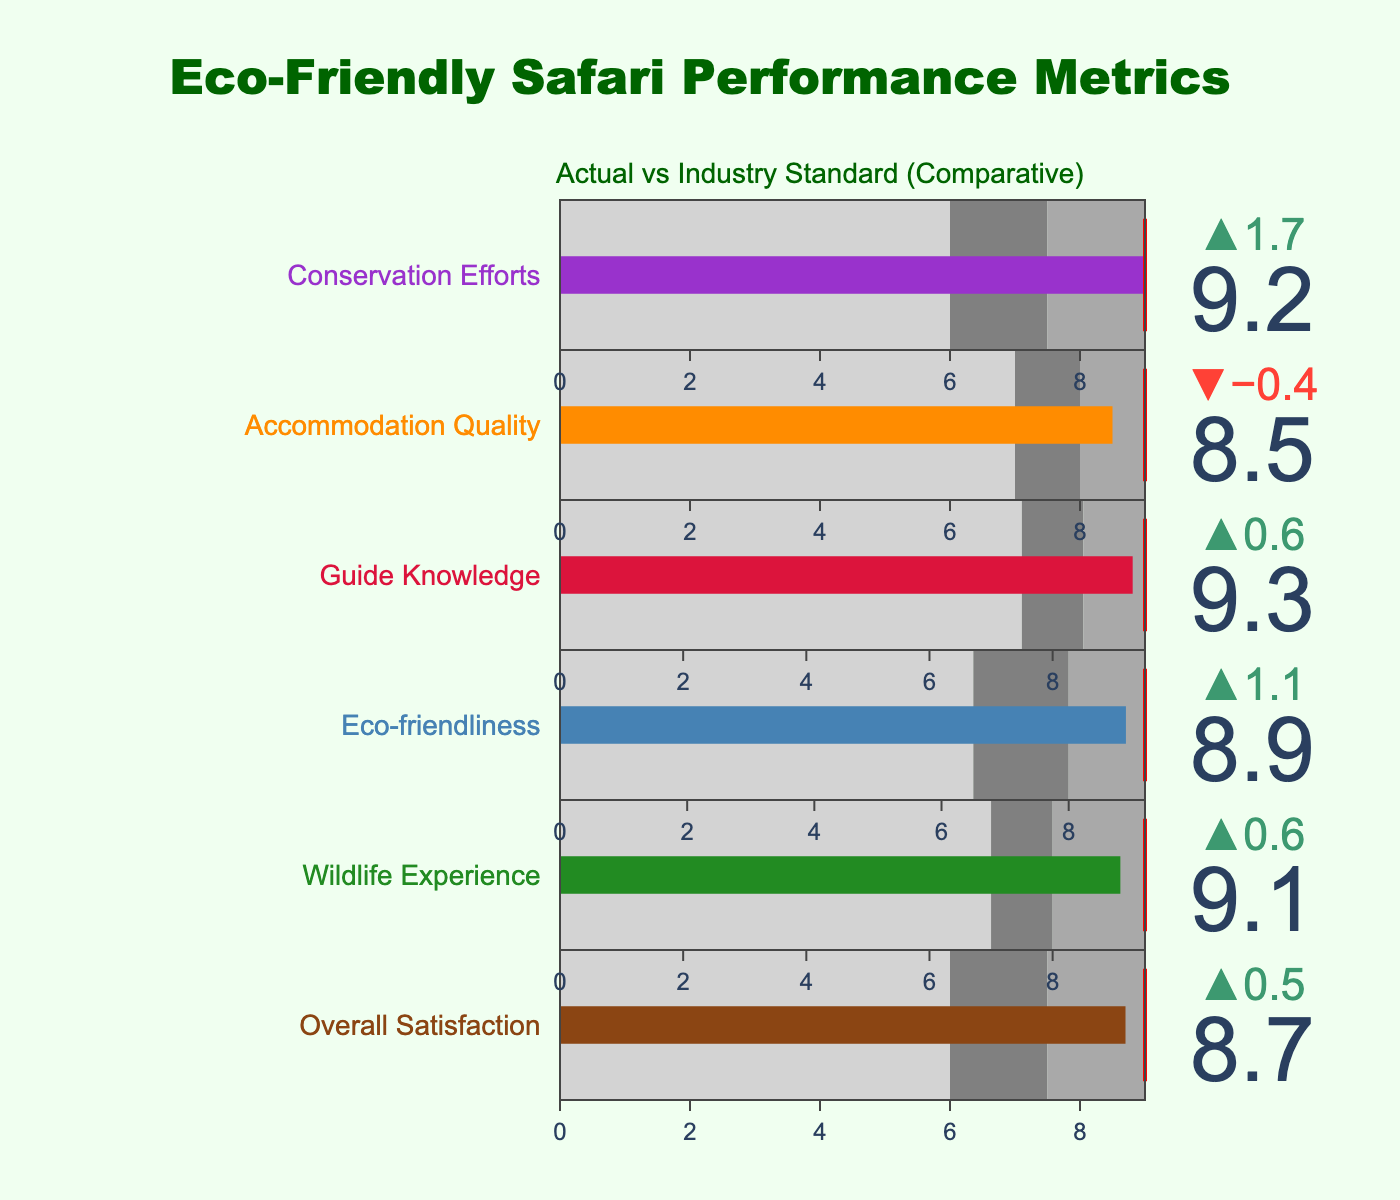What's the title of the figure? The title is prominently placed at the top of the figure and is written in a large, green font. It reads "Eco-Friendly Safari Performance Metrics."
Answer: Eco-Friendly Safari Performance Metrics What is the Actual customer satisfaction rating for Accommodation Quality? The Actual rating for Accommodation Quality is the bar value in the corresponding bullet chart. It's shown as 8.5.
Answer: 8.5 Which category has the highest Actual customer satisfaction rating? By comparing the Actual values in the bullet charts, we observe that Guide Knowledge has the highest Actual value at 9.3.
Answer: Guide Knowledge How does the Comparative rating for Wildlife Experience compare to the Actual rating? The Comparative rating for Wildlife Experience is 8.5 while the Actual rating is 9.1. The Actual rating is higher by 0.6.
Answer: Higher by 0.6 What's the difference between the Target and Comparative ratings for Eco-friendliness? The Target rating for Eco-friendliness is 9.2, and the Comparative rating is 7.8. Their difference is 9.2 - 7.8 = 1.4.
Answer: 1.4 For which category is the Actual rating below the Target rating? For each bullet chart, compare the Actual value to the Target value. Accommodation Quality has an Actual rating of 8.5, which is below the Target rating of 9.0.
Answer: Accommodation Quality Which category has the largest gap between Actual and Comparative ratings, and what is the value? By calculating the differences for each category, the largest gap is found in Conservation Efforts. The Actual rating is 9.2 and the Comparative rating is 7.5. The gap is 9.2 - 7.5 = 1.7.
Answer: Conservation Efforts, 1.7 Are there any categories where the Actual rating meets or exceeds the Target rating? By comparing the Actual ratings to the Target values in all bullet charts, we see that all categories except Accommodation Quality meet or exceed their respective Target ratings.
Answer: Yes What can be said about the industry standard (Comparative rating) for Accommodation Quality? The Comparative rating for Accommodation Quality is 8.9, which is higher than the Actual rating of 8.5, indicating that industry standards are higher than the company's performance in this category.
Answer: Higher than company's performance What is indicated by the red lines in the bullet charts? The red line represents the target value for each category, showing the benchmark or goal the company aims for in each performance metric.
Answer: Target values 